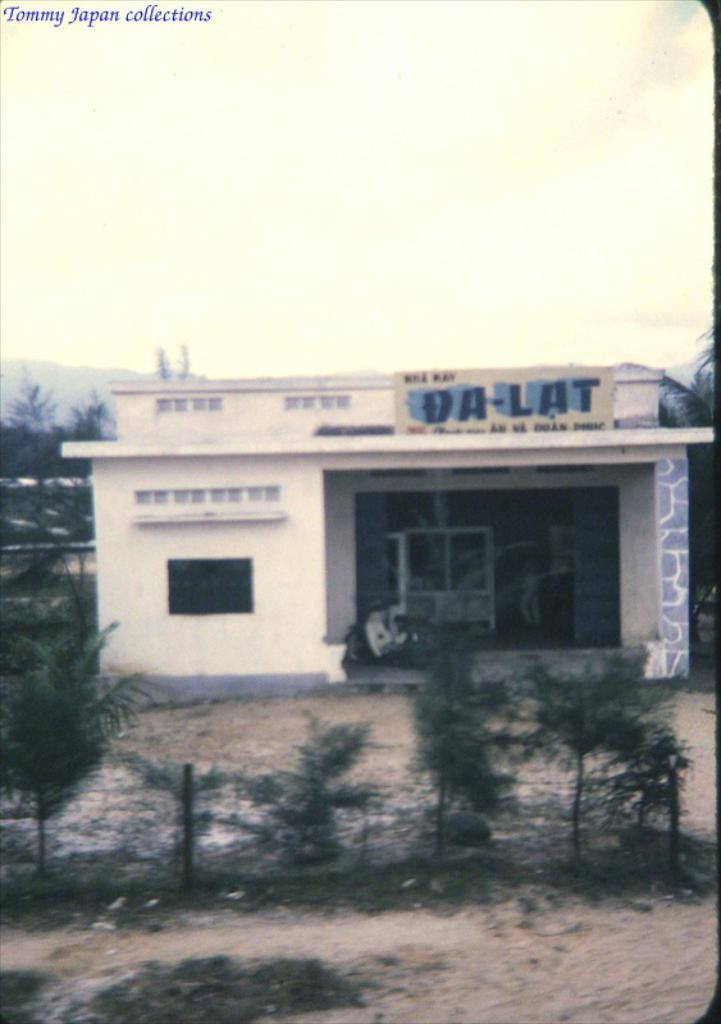Can you describe this image briefly? Here, we can see a shop, there are some green trees, at the top there is a sky. 